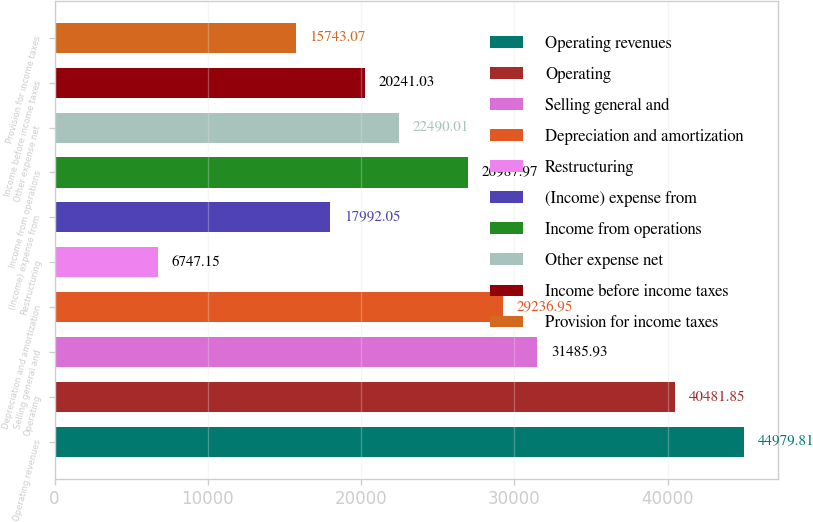Convert chart to OTSL. <chart><loc_0><loc_0><loc_500><loc_500><bar_chart><fcel>Operating revenues<fcel>Operating<fcel>Selling general and<fcel>Depreciation and amortization<fcel>Restructuring<fcel>(Income) expense from<fcel>Income from operations<fcel>Other expense net<fcel>Income before income taxes<fcel>Provision for income taxes<nl><fcel>44979.8<fcel>40481.8<fcel>31485.9<fcel>29237<fcel>6747.15<fcel>17992<fcel>26988<fcel>22490<fcel>20241<fcel>15743.1<nl></chart> 